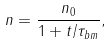<formula> <loc_0><loc_0><loc_500><loc_500>n = \frac { n _ { 0 } } { 1 + t / \tau _ { b m } } ,</formula> 